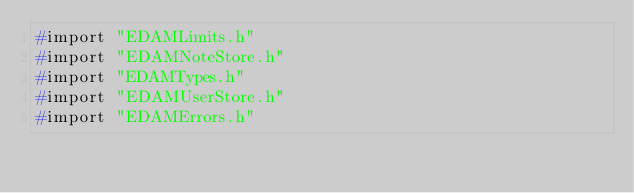<code> <loc_0><loc_0><loc_500><loc_500><_C_>#import "EDAMLimits.h"
#import "EDAMNoteStore.h"
#import "EDAMTypes.h"
#import "EDAMUserStore.h"
#import "EDAMErrors.h"</code> 